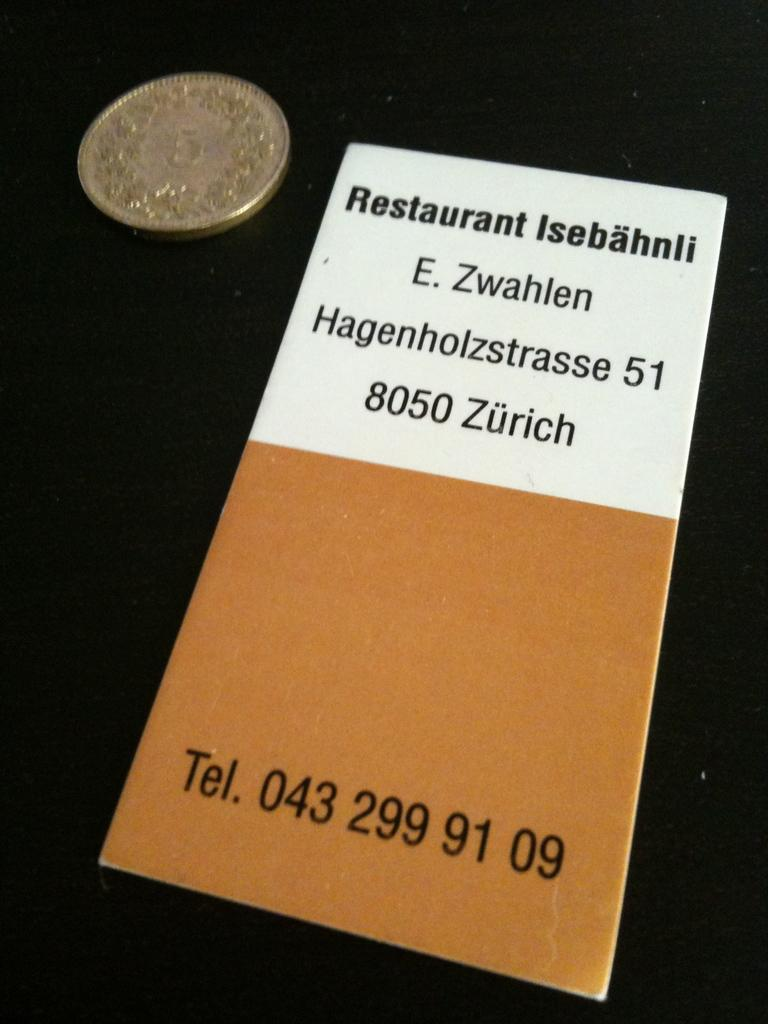<image>
Provide a brief description of the given image. A pamphlet for a Restaurant called Isebahnli has the telephone number at the bottom. 